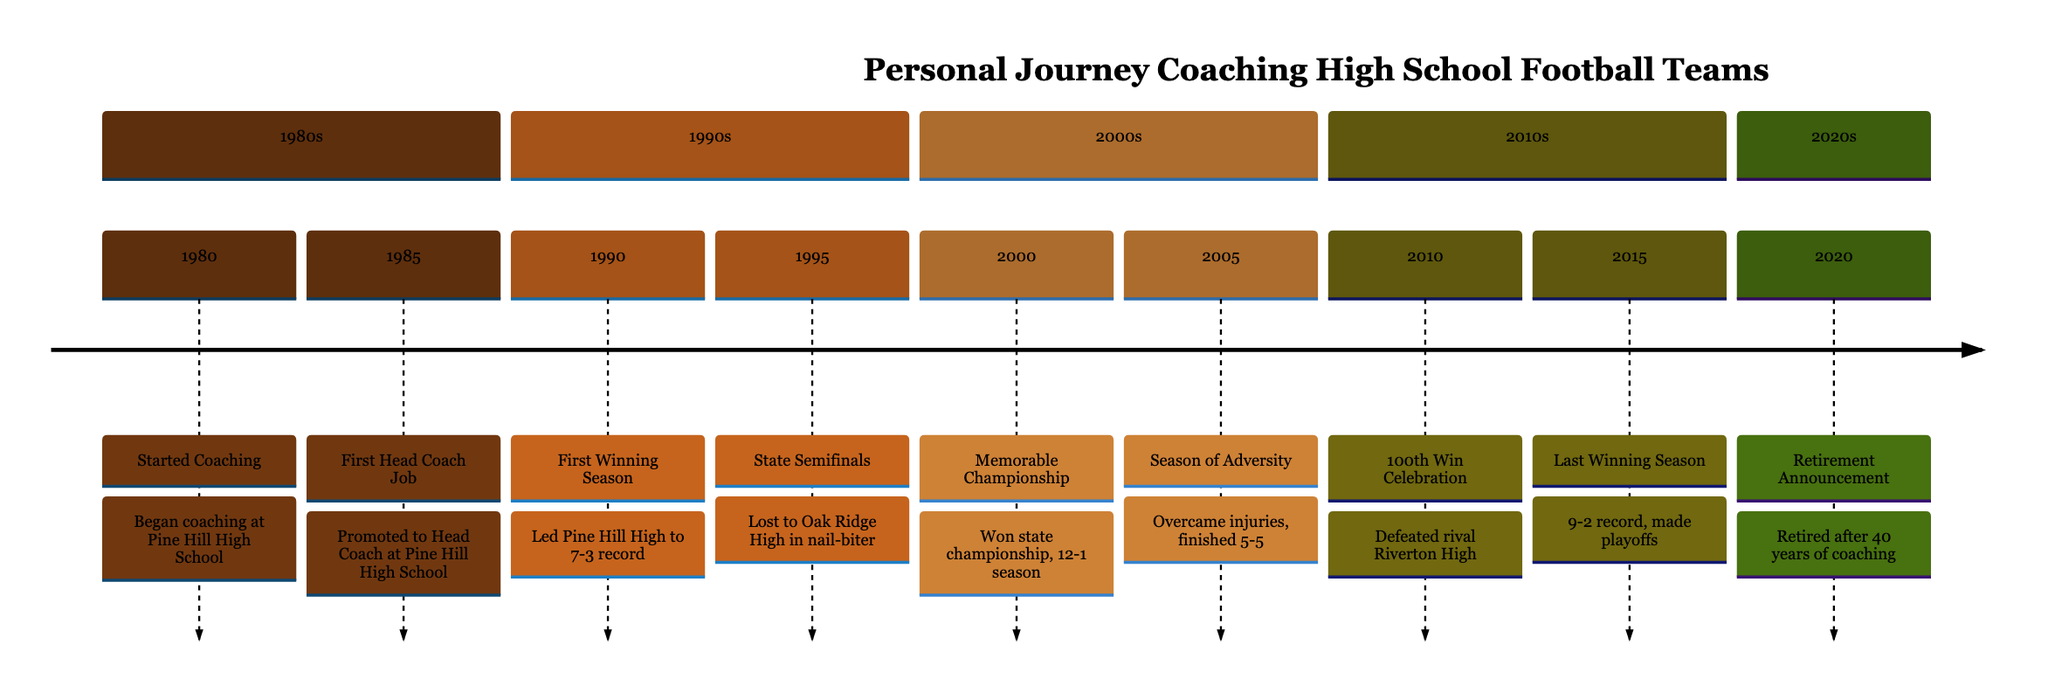What year did coaching begin? The timeline shows that coaching began in 1980 at Pine Hill High School.
Answer: 1980 What event occurred in 1990? The timeline indicates that in 1990, the first winning season was achieved with a record of 7-3.
Answer: First Winning Season How many winning seasons are listed in the timeline? By reviewing the timeline, two winning seasons are highlighted: one in 1990 and the last one in 2015.
Answer: 2 What was the outcome of the state semifinals in 1995? The timeline specifies that in 1995, the team lost to Oak Ridge High in a close game during the state semifinals.
Answer: Lost Which year marks the 100th career win? According to the timeline, the year 2010 is noted for the celebration of the 100th career win as a head coach.
Answer: 2010 What was the record in the last winning season? The timeline reveals that the last winning season, in 2015, ended with a record of 9-2.
Answer: 9-2 What notable event happened in the year 2000? The timeline states that in 2000, a memorable championship was won against Davidson High, finishing the season with a 12-1 record.
Answer: Memorable Championship How many years did the coaching career span? By examining the timeline, we can see that the coaching career spanned from 1980 to 2020, which totals 40 years.
Answer: 40 years What significant event happened in 2020? The timeline highlights that in 2020, the retirement announcement was made after 40 years of coaching.
Answer: Retirement Announcement 